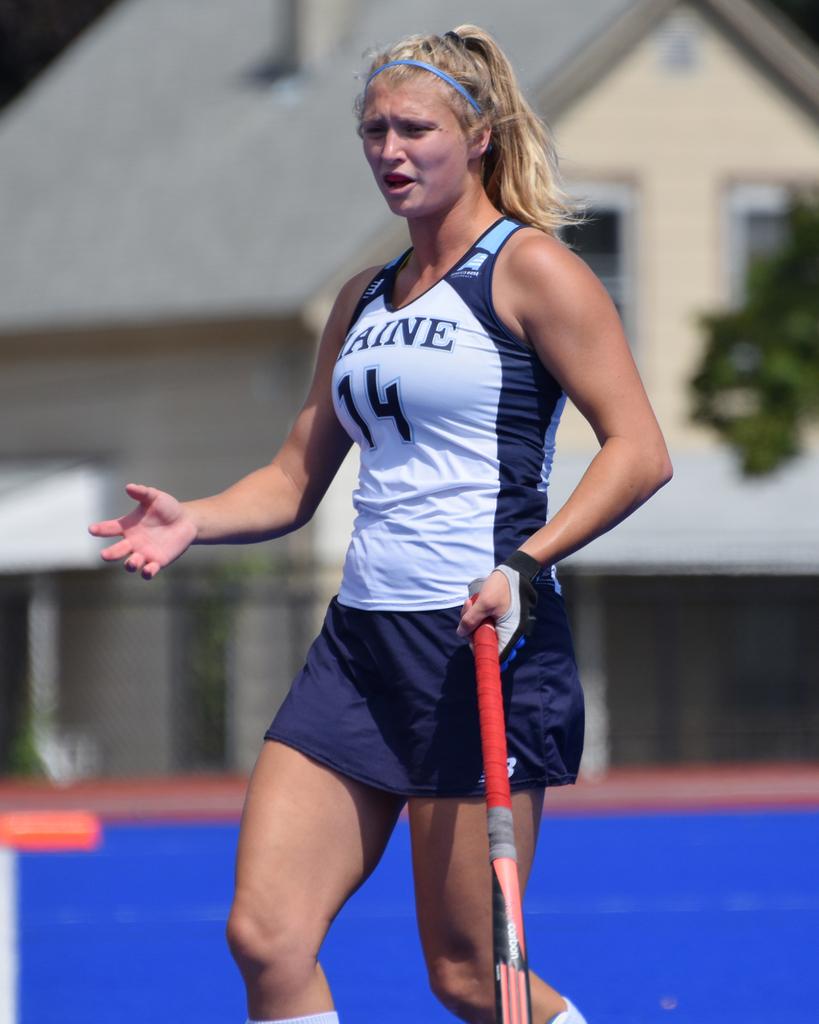Which state does she attend school.in?
Provide a succinct answer. Maine. 